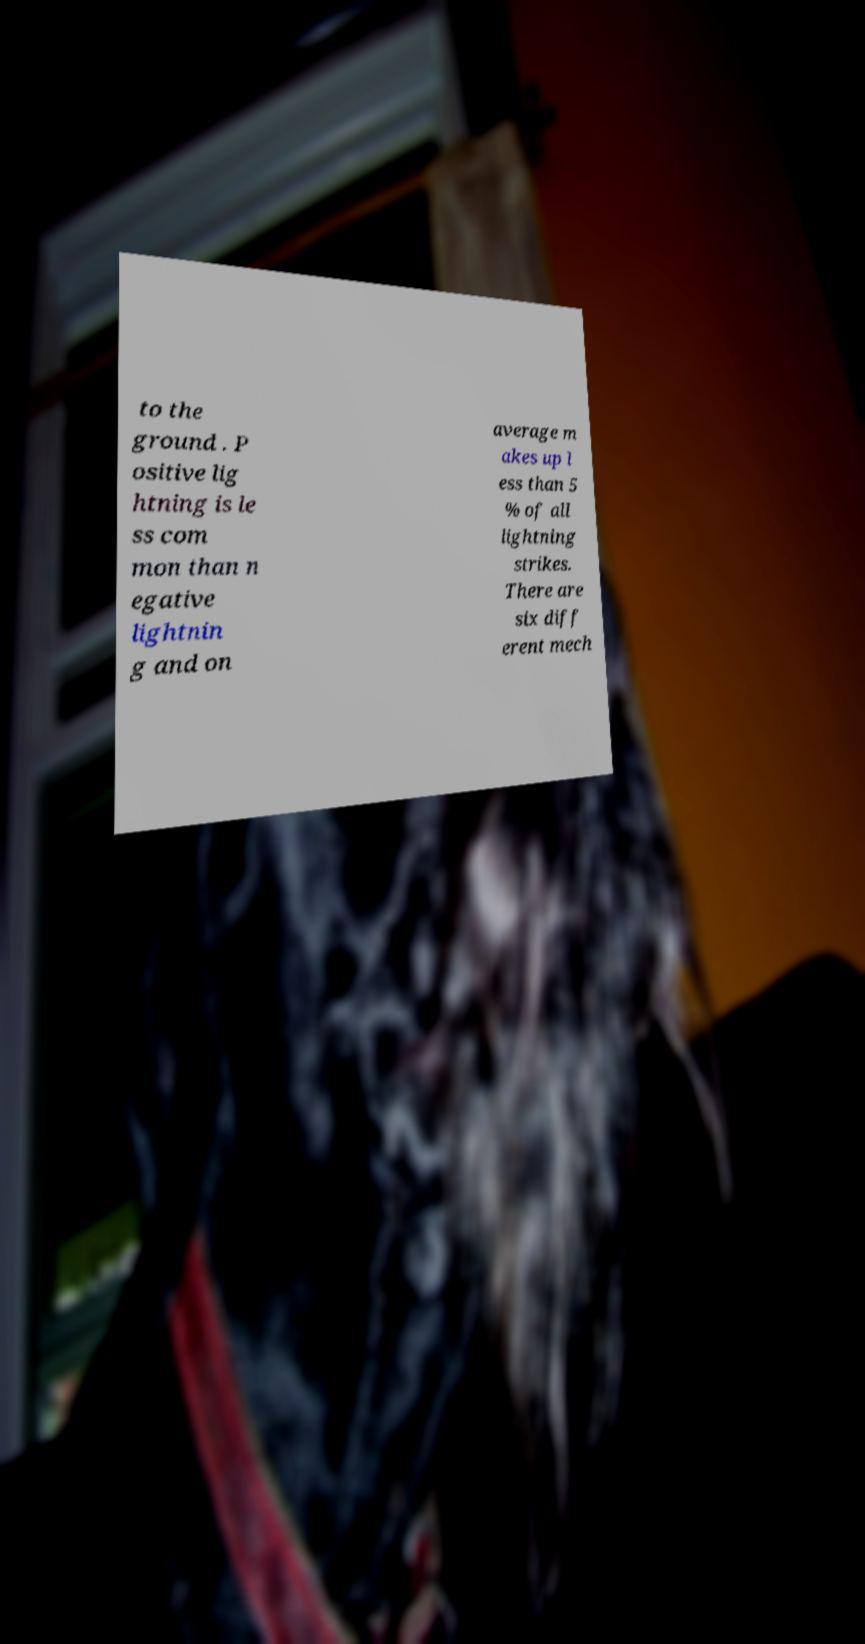For documentation purposes, I need the text within this image transcribed. Could you provide that? to the ground . P ositive lig htning is le ss com mon than n egative lightnin g and on average m akes up l ess than 5 % of all lightning strikes. There are six diff erent mech 